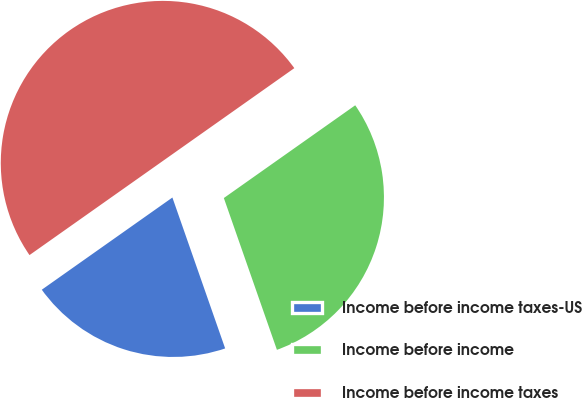Convert chart to OTSL. <chart><loc_0><loc_0><loc_500><loc_500><pie_chart><fcel>Income before income taxes-US<fcel>Income before income<fcel>Income before income taxes<nl><fcel>20.57%<fcel>29.43%<fcel>50.0%<nl></chart> 